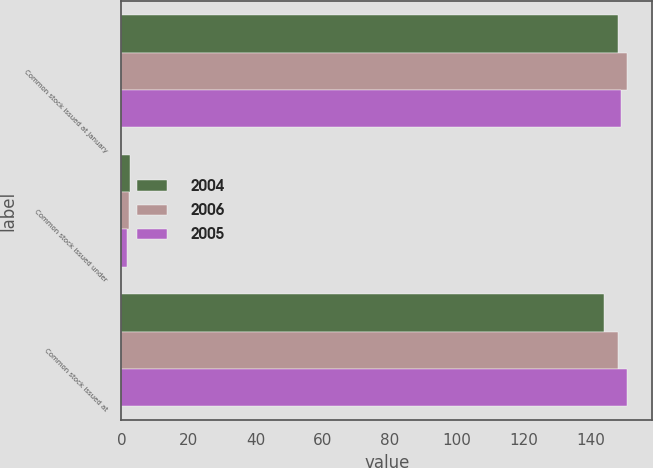Convert chart to OTSL. <chart><loc_0><loc_0><loc_500><loc_500><stacked_bar_chart><ecel><fcel>Common stock issued at January<fcel>Common stock issued under<fcel>Common stock issued at<nl><fcel>2004<fcel>148<fcel>2.5<fcel>143.8<nl><fcel>2006<fcel>150.7<fcel>2.1<fcel>148<nl><fcel>2005<fcel>148.9<fcel>1.8<fcel>150.7<nl></chart> 